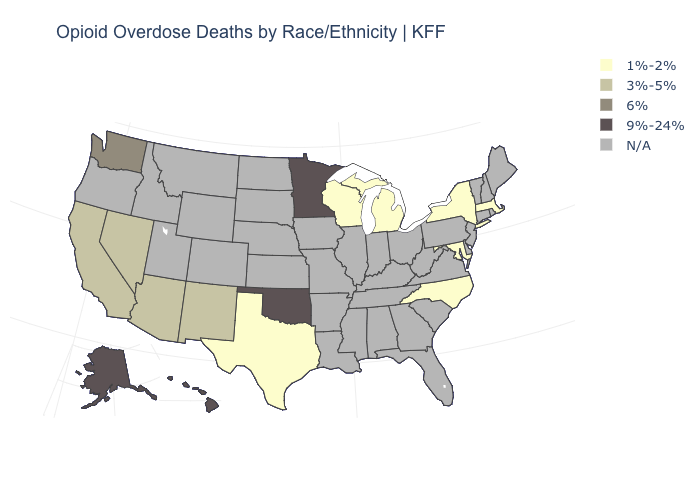Is the legend a continuous bar?
Write a very short answer. No. Name the states that have a value in the range 6%?
Quick response, please. Washington. What is the value of Connecticut?
Keep it brief. N/A. How many symbols are there in the legend?
Concise answer only. 5. What is the value of Rhode Island?
Give a very brief answer. N/A. Among the states that border Connecticut , which have the highest value?
Give a very brief answer. Massachusetts, New York. Which states have the lowest value in the USA?
Write a very short answer. Maryland, Massachusetts, Michigan, New York, North Carolina, Texas, Wisconsin. Does Wisconsin have the lowest value in the MidWest?
Quick response, please. Yes. Which states have the highest value in the USA?
Short answer required. Alaska, Hawaii, Minnesota, Oklahoma. Name the states that have a value in the range 3%-5%?
Be succinct. Arizona, California, Nevada, New Mexico. What is the value of North Carolina?
Be succinct. 1%-2%. What is the value of Maryland?
Quick response, please. 1%-2%. What is the highest value in the USA?
Short answer required. 9%-24%. 